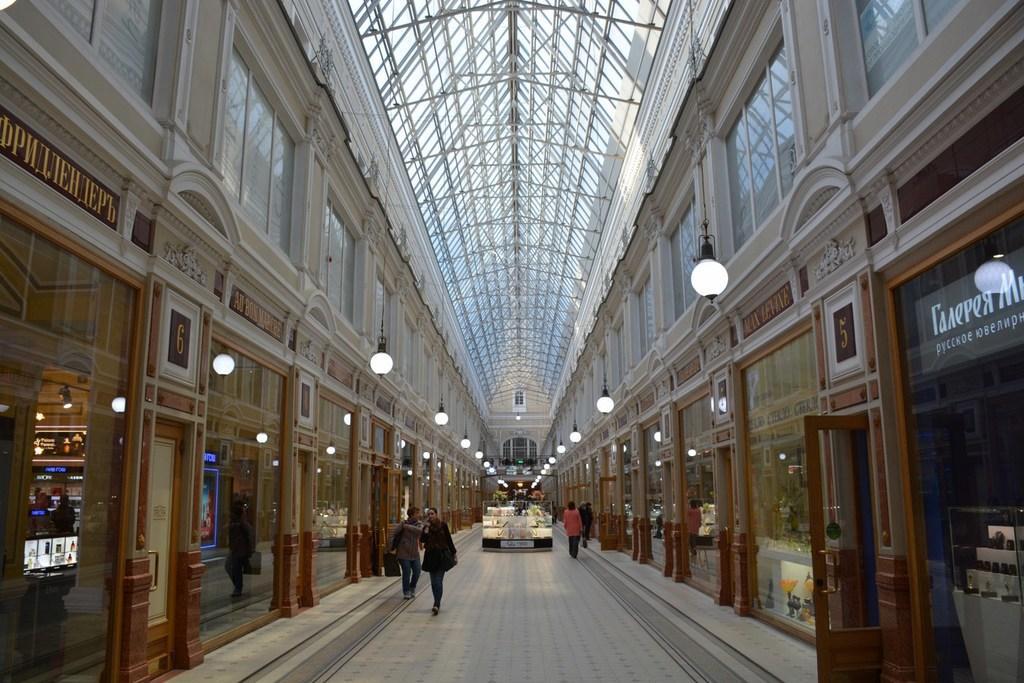Please provide a concise description of this image. In this picture I can see people on the floor. In the background I can see lights, glass wall, doors and ceiling. 